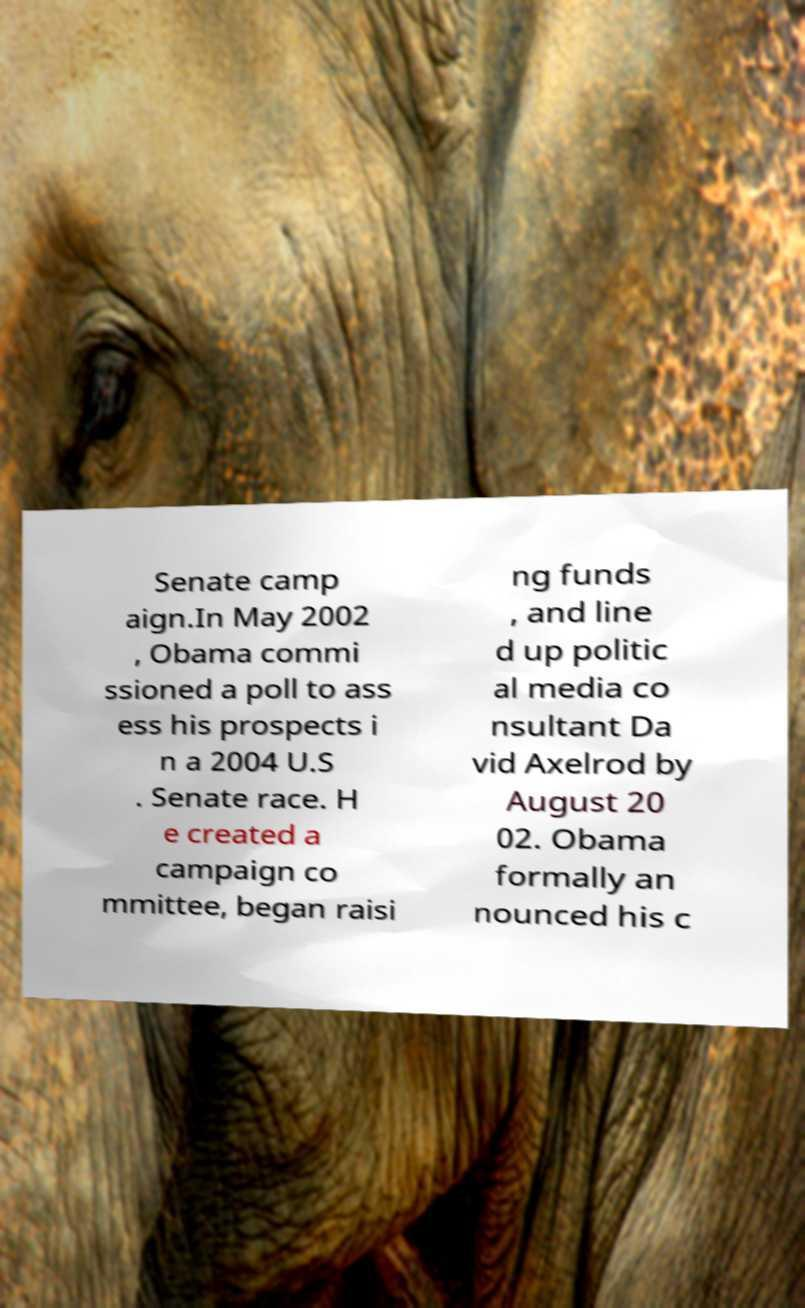There's text embedded in this image that I need extracted. Can you transcribe it verbatim? Senate camp aign.In May 2002 , Obama commi ssioned a poll to ass ess his prospects i n a 2004 U.S . Senate race. H e created a campaign co mmittee, began raisi ng funds , and line d up politic al media co nsultant Da vid Axelrod by August 20 02. Obama formally an nounced his c 